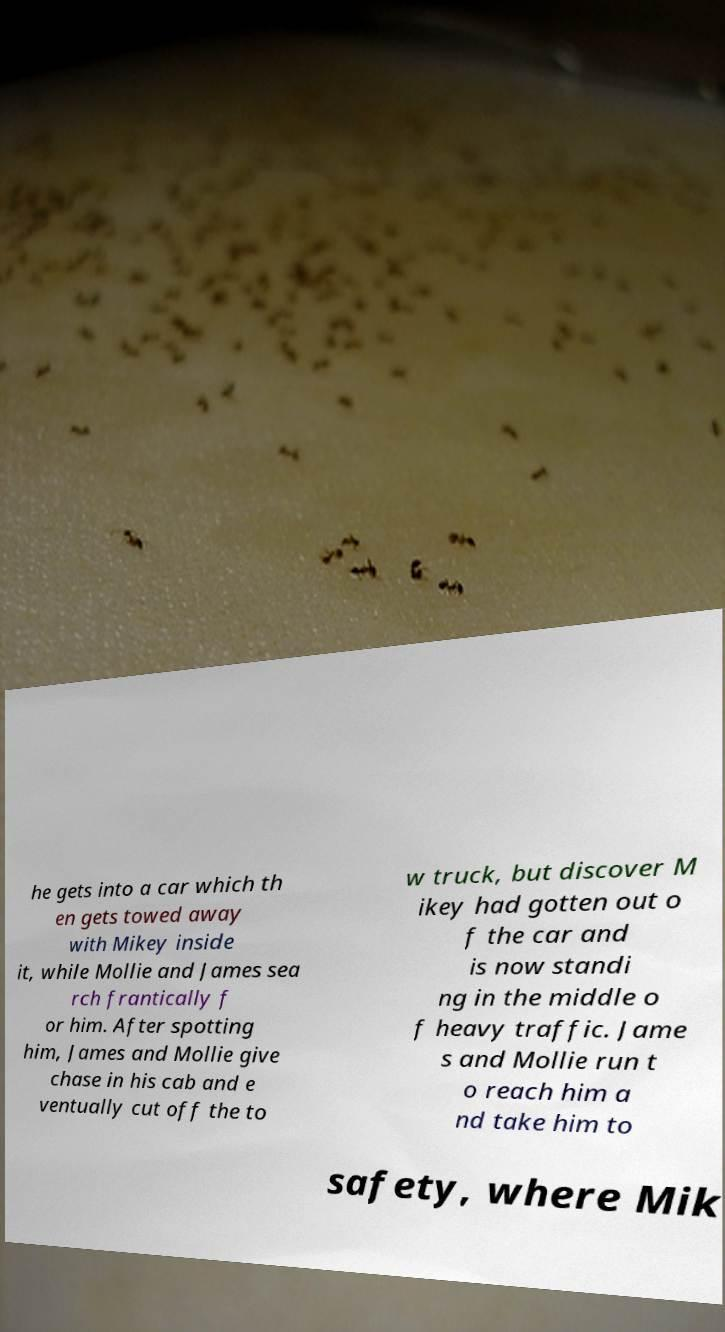Can you read and provide the text displayed in the image?This photo seems to have some interesting text. Can you extract and type it out for me? he gets into a car which th en gets towed away with Mikey inside it, while Mollie and James sea rch frantically f or him. After spotting him, James and Mollie give chase in his cab and e ventually cut off the to w truck, but discover M ikey had gotten out o f the car and is now standi ng in the middle o f heavy traffic. Jame s and Mollie run t o reach him a nd take him to safety, where Mik 